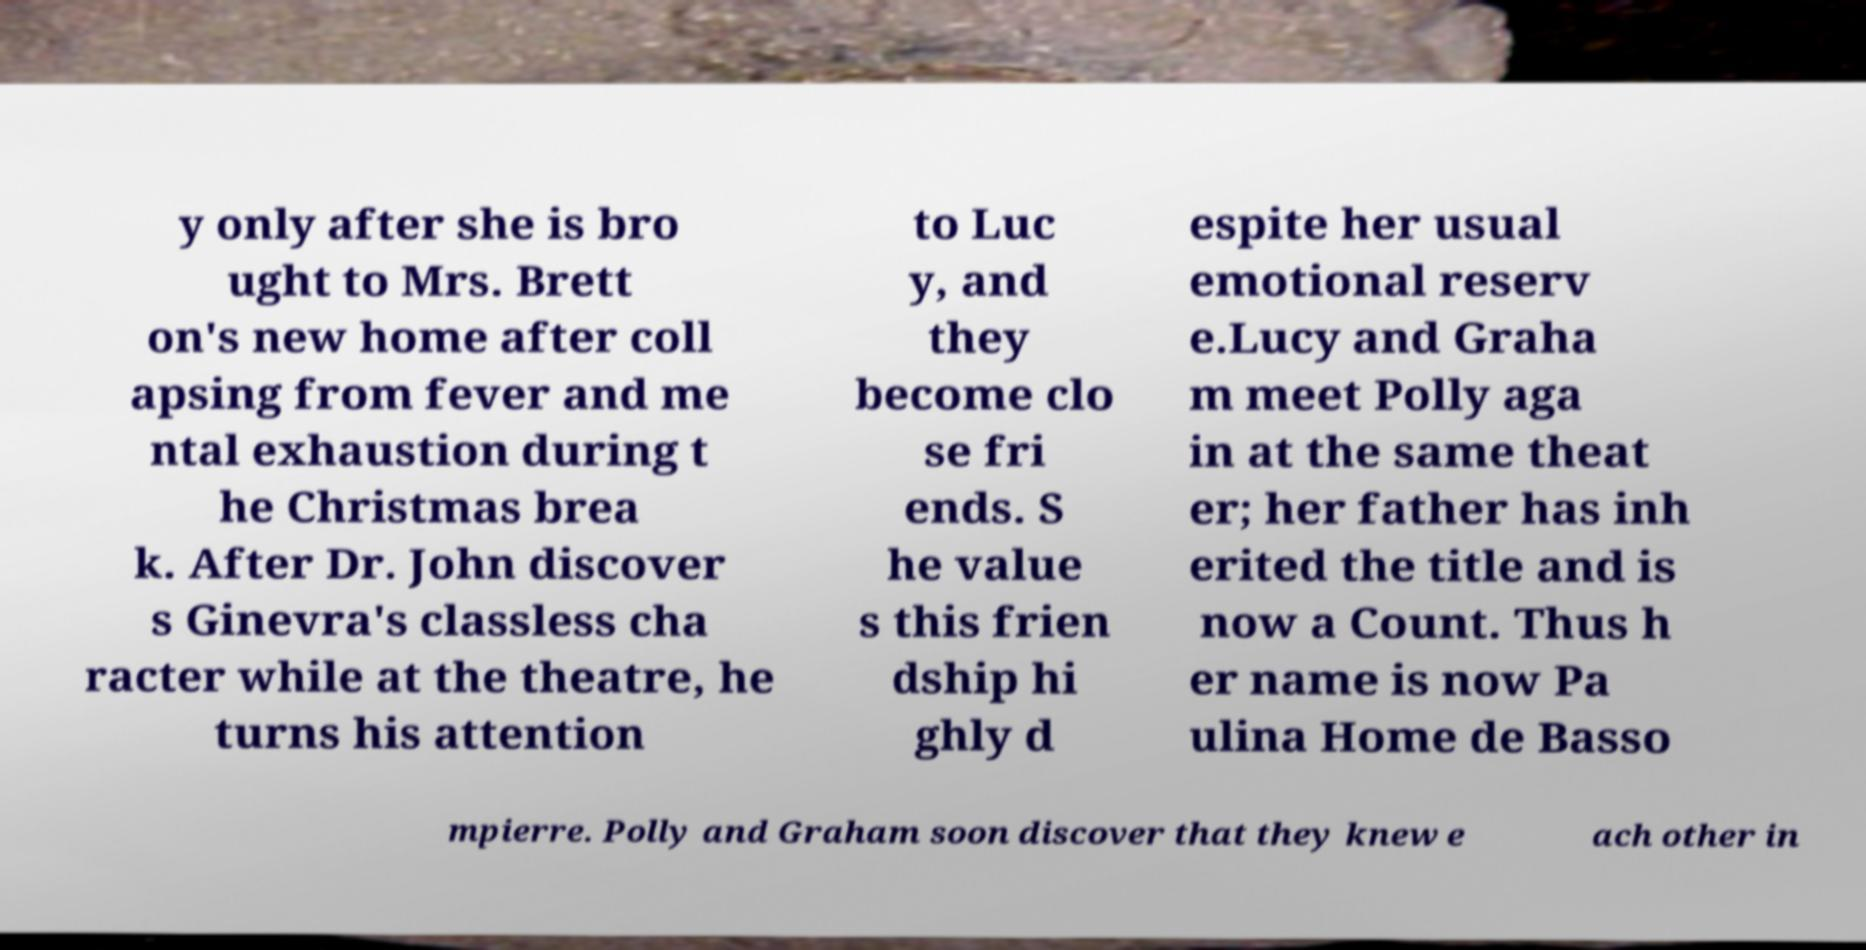There's text embedded in this image that I need extracted. Can you transcribe it verbatim? y only after she is bro ught to Mrs. Brett on's new home after coll apsing from fever and me ntal exhaustion during t he Christmas brea k. After Dr. John discover s Ginevra's classless cha racter while at the theatre, he turns his attention to Luc y, and they become clo se fri ends. S he value s this frien dship hi ghly d espite her usual emotional reserv e.Lucy and Graha m meet Polly aga in at the same theat er; her father has inh erited the title and is now a Count. Thus h er name is now Pa ulina Home de Basso mpierre. Polly and Graham soon discover that they knew e ach other in 